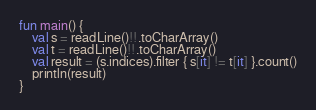<code> <loc_0><loc_0><loc_500><loc_500><_Kotlin_>fun main() {
    val s = readLine()!!.toCharArray()
    val t = readLine()!!.toCharArray()
    val result = (s.indices).filter { s[it] != t[it] }.count()
    println(result)
}</code> 